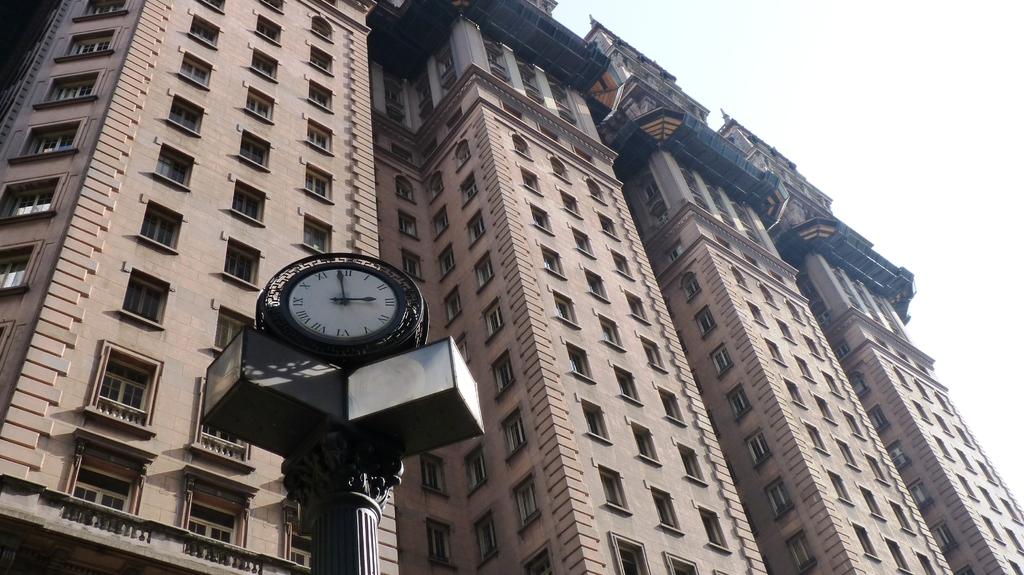What time is it?
Give a very brief answer. 3:00. Does the clock display the number 6 in roman numerals?
Your answer should be very brief. Yes. 